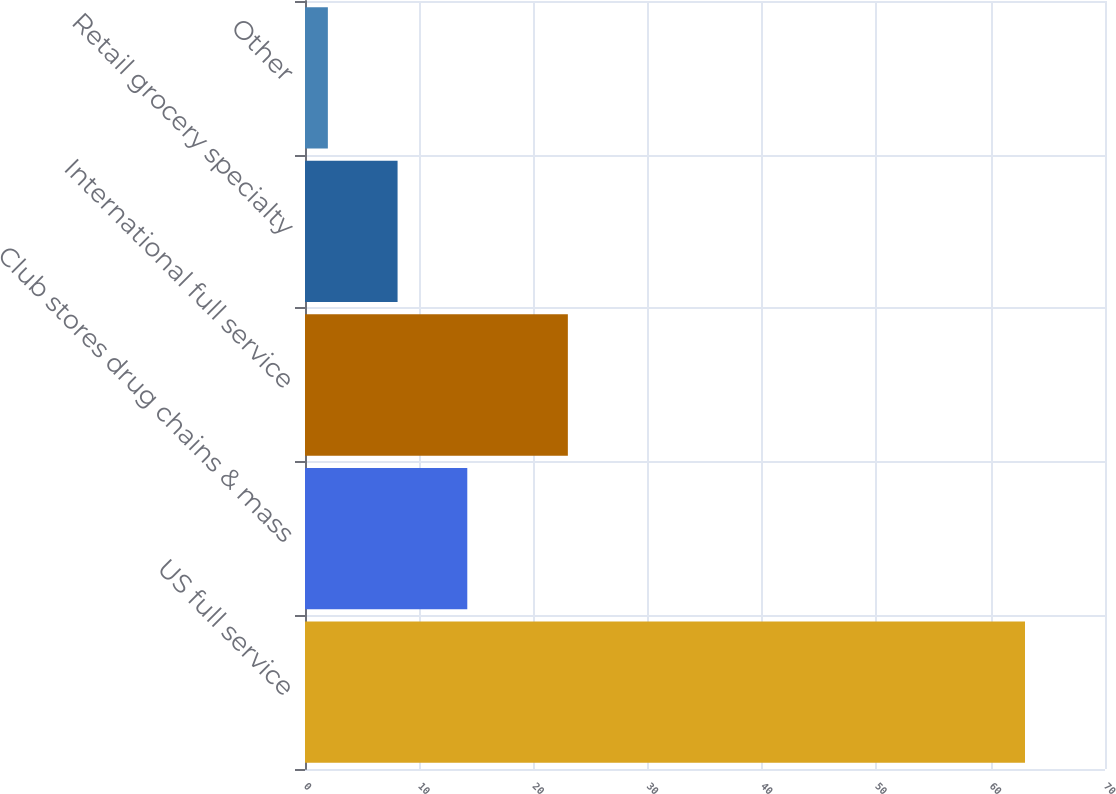<chart> <loc_0><loc_0><loc_500><loc_500><bar_chart><fcel>US full service<fcel>Club stores drug chains & mass<fcel>International full service<fcel>Retail grocery specialty<fcel>Other<nl><fcel>63<fcel>14.2<fcel>23<fcel>8.1<fcel>2<nl></chart> 